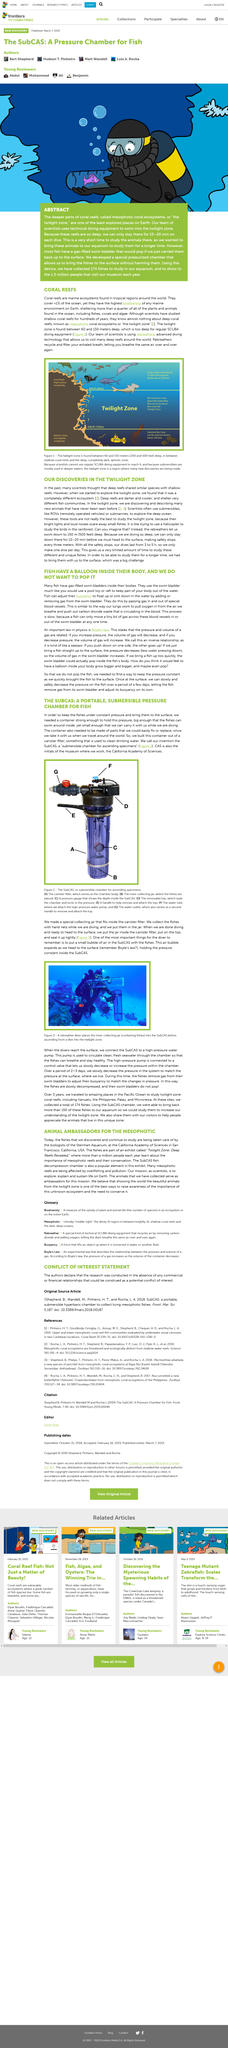Outline some significant characteristics in this image. In order to keep fish under constant pressure and bring them to the surface, a container with sufficient strength to withstand the pressure is required. This container must be large enough for the fish to swim around inside, yet small enough to be easily carried while driving. The above picture depicts a submersible chamber designed for the purpose of ascending specimens. The twilight zone region of coral ecosystems is illustrated in figure 1. Coral reefs cover less than one percent of the ocean. As the divers ascend to the surface, the small air bubble in the SubCAS expands. 